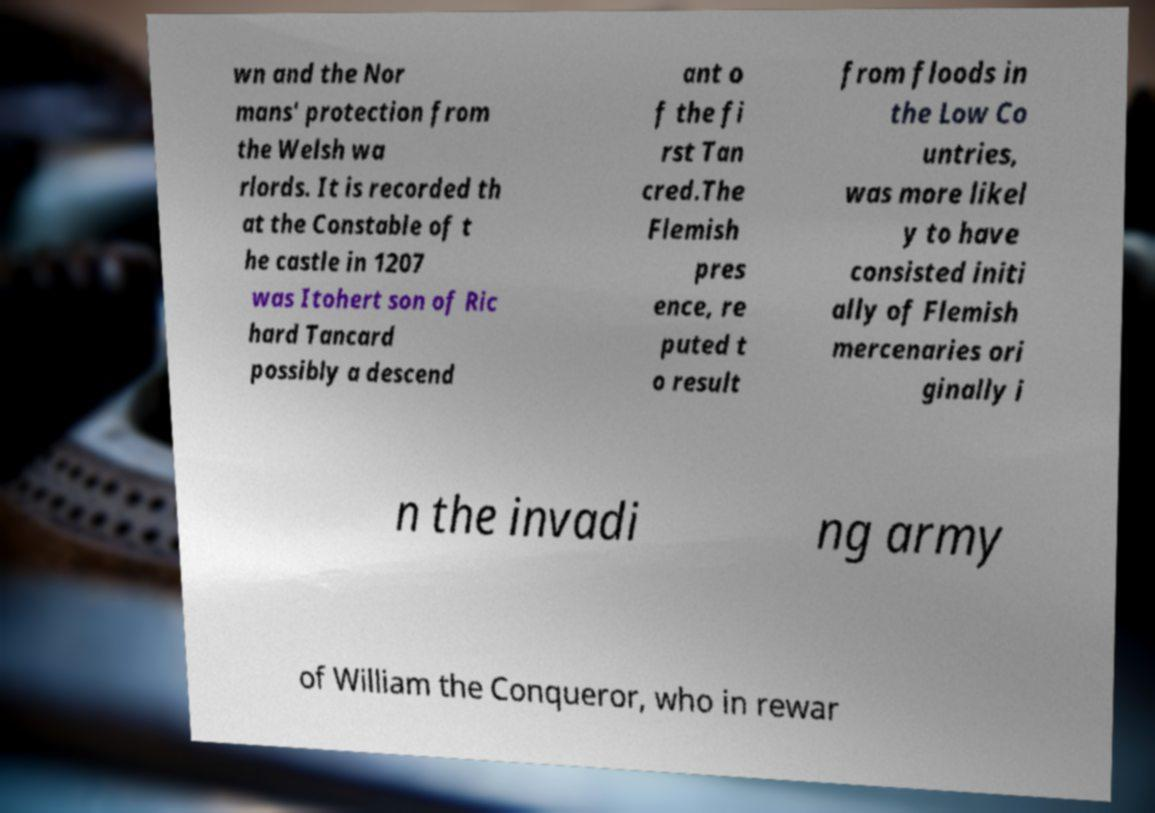Could you extract and type out the text from this image? wn and the Nor mans' protection from the Welsh wa rlords. It is recorded th at the Constable of t he castle in 1207 was Itohert son of Ric hard Tancard possibly a descend ant o f the fi rst Tan cred.The Flemish pres ence, re puted t o result from floods in the Low Co untries, was more likel y to have consisted initi ally of Flemish mercenaries ori ginally i n the invadi ng army of William the Conqueror, who in rewar 